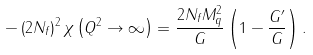<formula> <loc_0><loc_0><loc_500><loc_500>- \left ( 2 N _ { f } \right ) ^ { 2 } \chi \left ( Q ^ { 2 } \rightarrow \infty \right ) = \frac { 2 N _ { f } M _ { q } ^ { 2 } } { G } \left ( 1 - \frac { G ^ { \prime } } { G } \right ) .</formula> 